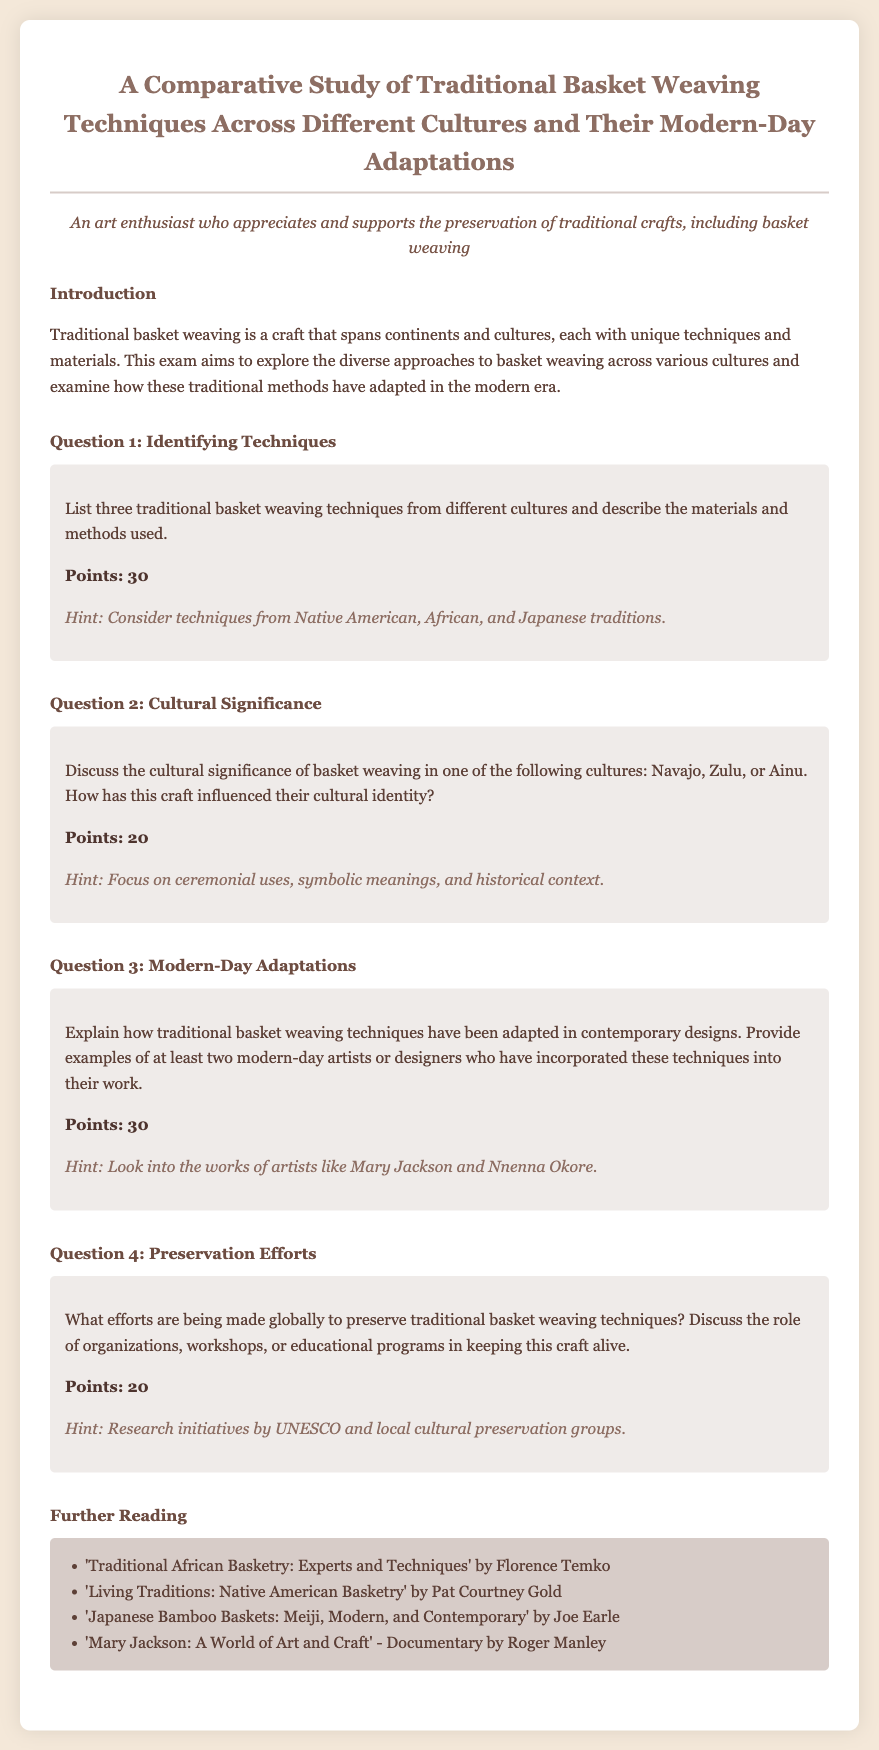what is the title of the exam? The title is clearly stated at the top of the document under the heading.
Answer: A Comparative Study of Traditional Basket Weaving Techniques Across Different Cultures and Their Modern-Day Adaptations how many points is Question 1 worth? The points for each question are listed immediately below the corresponding question.
Answer: 30 name one traditional basket weaving technique mentioned for Native American culture. The techniques are described in the questions, specifically referencing Native American traditions.
Answer: Coiling who is one modern-day artist mentioned in the document? The hint section for Question 3 provides names of contemporary artists.
Answer: Mary Jackson what cultural significance is discussed in relation to Zulu basket weaving? The question prompts discussion about the cultural significance in one of the specified cultures.
Answer: Cultural identity what type of organizations are mentioned in the context of preserving basket weaving? The answer can be found in the text regarding preservation efforts where specific organizations are called out.
Answer: UNESCO how many further reading titles are listed in the document? The number of titles is determined by counting the items in the further reading section.
Answer: 4 what is one material commonly used in traditional basket weaving? The materials used are part of the description of traditional techniques referenced in the exam questions.
Answer: Bamboo which culture is focused on in Question 2 for discussing cultural significance? The options for culture in the question help identify the focus.
Answer: Navajo 